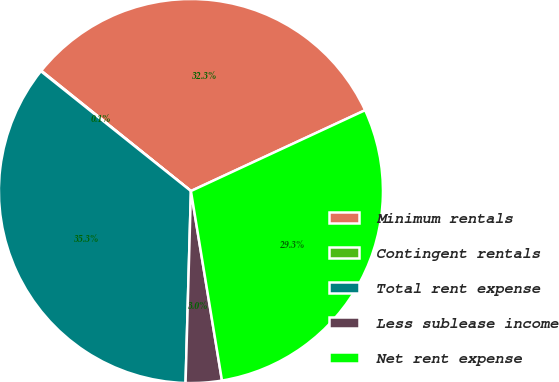Convert chart to OTSL. <chart><loc_0><loc_0><loc_500><loc_500><pie_chart><fcel>Minimum rentals<fcel>Contingent rentals<fcel>Total rent expense<fcel>Less sublease income<fcel>Net rent expense<nl><fcel>32.31%<fcel>0.05%<fcel>35.28%<fcel>3.03%<fcel>29.33%<nl></chart> 